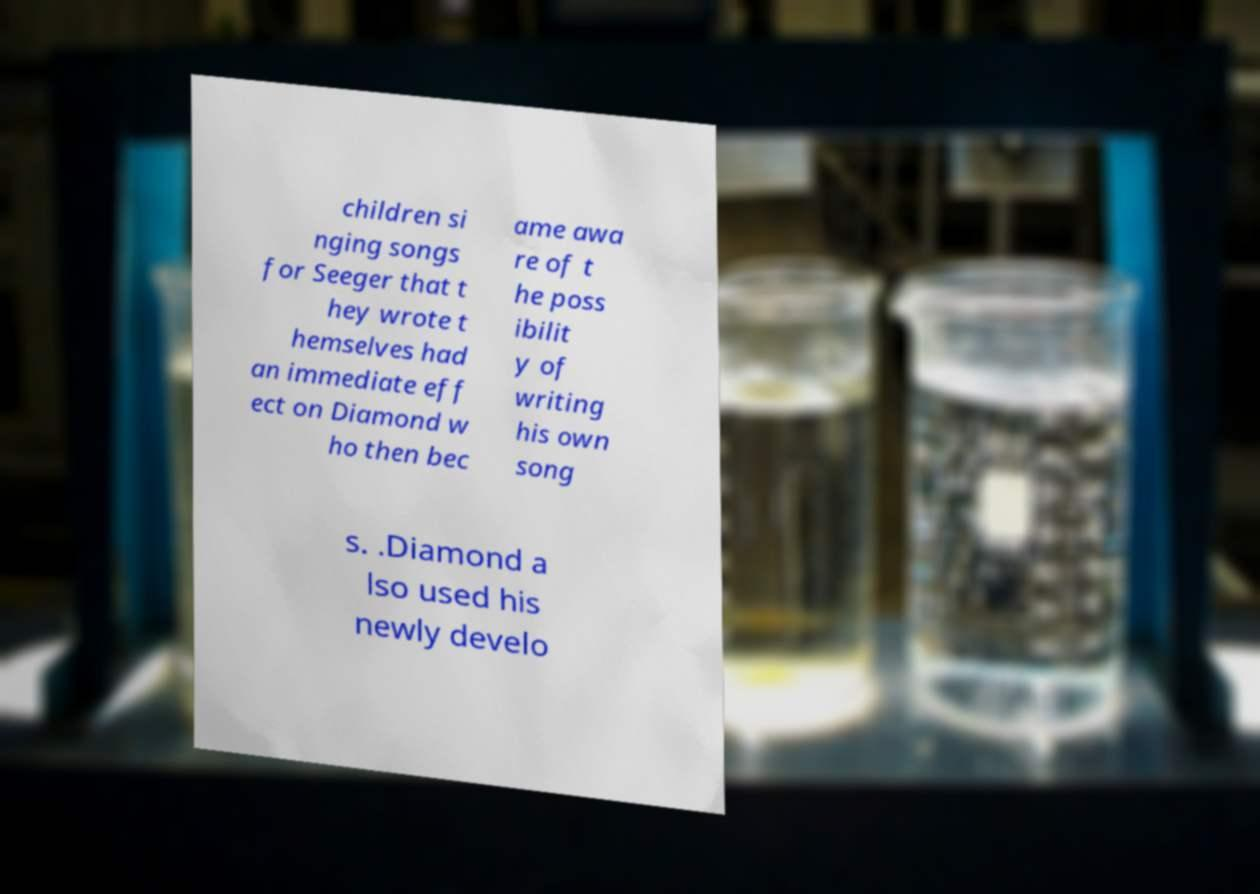What messages or text are displayed in this image? I need them in a readable, typed format. children si nging songs for Seeger that t hey wrote t hemselves had an immediate eff ect on Diamond w ho then bec ame awa re of t he poss ibilit y of writing his own song s. .Diamond a lso used his newly develo 